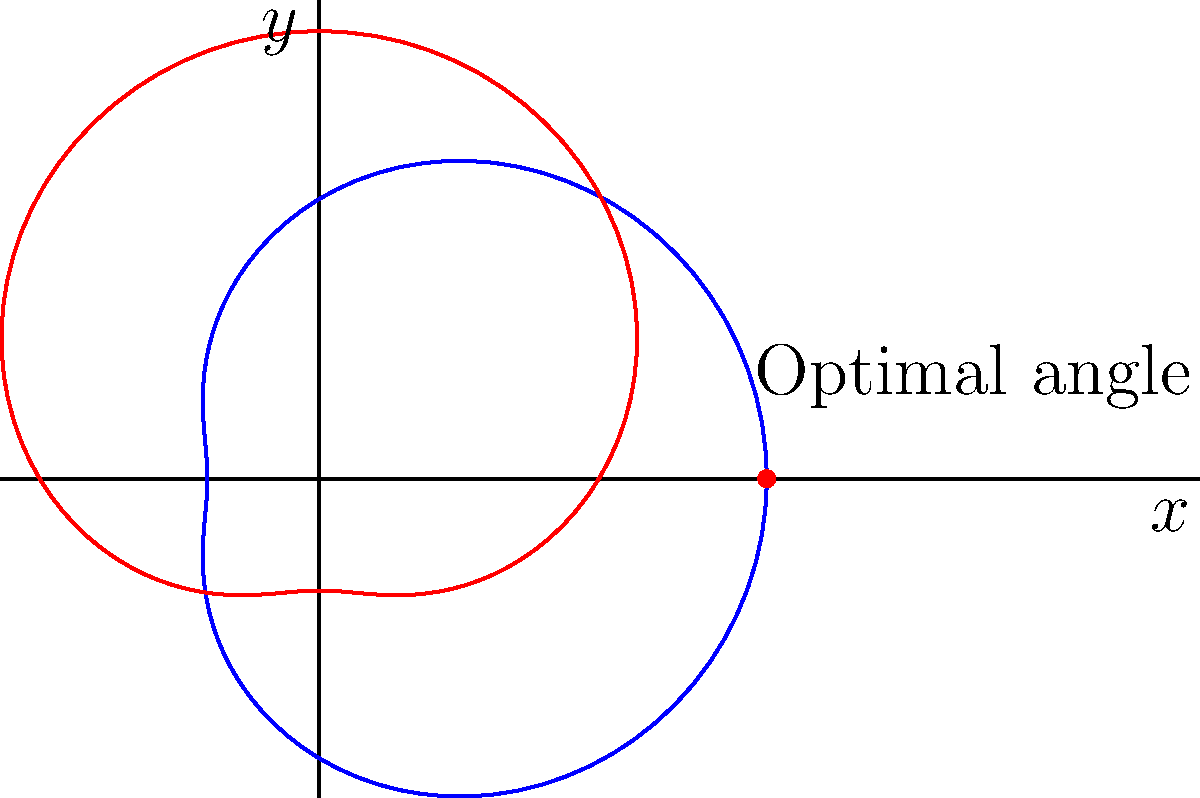As a water polo player, you're practicing your goal-shooting technique. The blue curve in the polar graph represents the power of your shot, while the red curve represents the accuracy. The optimal shooting angle occurs where these two factors intersect at the highest point. Based on the graph, at what angle (in degrees) should you aim for the optimal shot? To find the optimal shooting angle, we need to follow these steps:

1. Observe that the blue (power) and red (accuracy) curves intersect at multiple points.
2. Identify the intersection point that is furthest from the origin, as this represents the optimal balance of power and accuracy.
3. The highest intersection point appears to be at $(8,0)$ in the Cartesian plane.
4. To convert this to polar coordinates, we need to find the angle $\theta$ such that:
   
   $r \cos(\theta) = 8$ and $r \sin(\theta) = 0$

5. Since $\sin(\theta) = 0$, this occurs when $\theta = 0°$ or $180°$.
6. Given that the point is on the positive x-axis, we can conclude that $\theta = 0°$.

Therefore, the optimal shooting angle is 0°, which corresponds to a straight horizontal shot.
Answer: 0° 